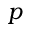Convert formula to latex. <formula><loc_0><loc_0><loc_500><loc_500>p</formula> 